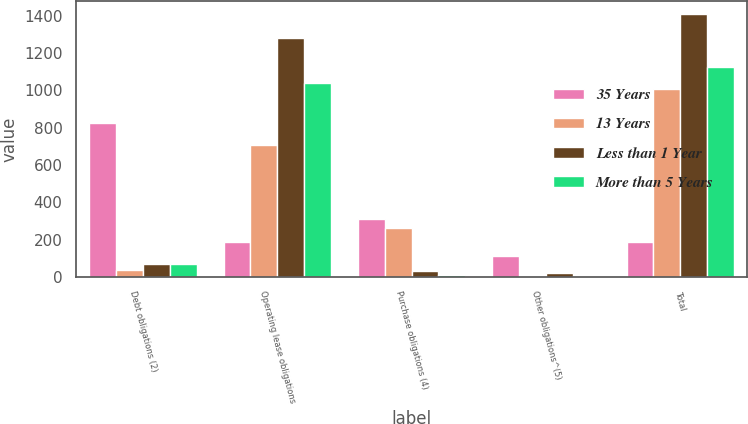<chart> <loc_0><loc_0><loc_500><loc_500><stacked_bar_chart><ecel><fcel>Debt obligations (2)<fcel>Operating lease obligations<fcel>Purchase obligations (4)<fcel>Other obligations^(5)<fcel>Total<nl><fcel>35 Years<fcel>825.4<fcel>186.9<fcel>308.3<fcel>109.7<fcel>186.9<nl><fcel>13 Years<fcel>34.7<fcel>706.7<fcel>264.1<fcel>3.3<fcel>1008.8<nl><fcel>Less than 1 Year<fcel>68.8<fcel>1281.3<fcel>34.2<fcel>22.8<fcel>1407.1<nl><fcel>More than 5 Years<fcel>68.8<fcel>1039.1<fcel>9.5<fcel>6.8<fcel>1124.2<nl></chart> 